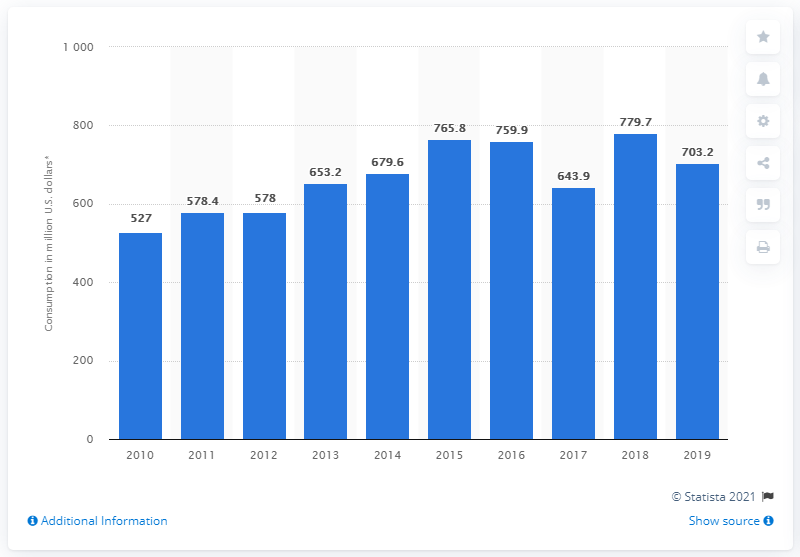Outline some significant characteristics in this image. In 2018, the amount of internal tourism consumption in Haiti was 779.7 million dollars. 